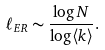Convert formula to latex. <formula><loc_0><loc_0><loc_500><loc_500>\ell _ { E R } \sim \frac { \log N } { \log \langle k \rangle } .</formula> 